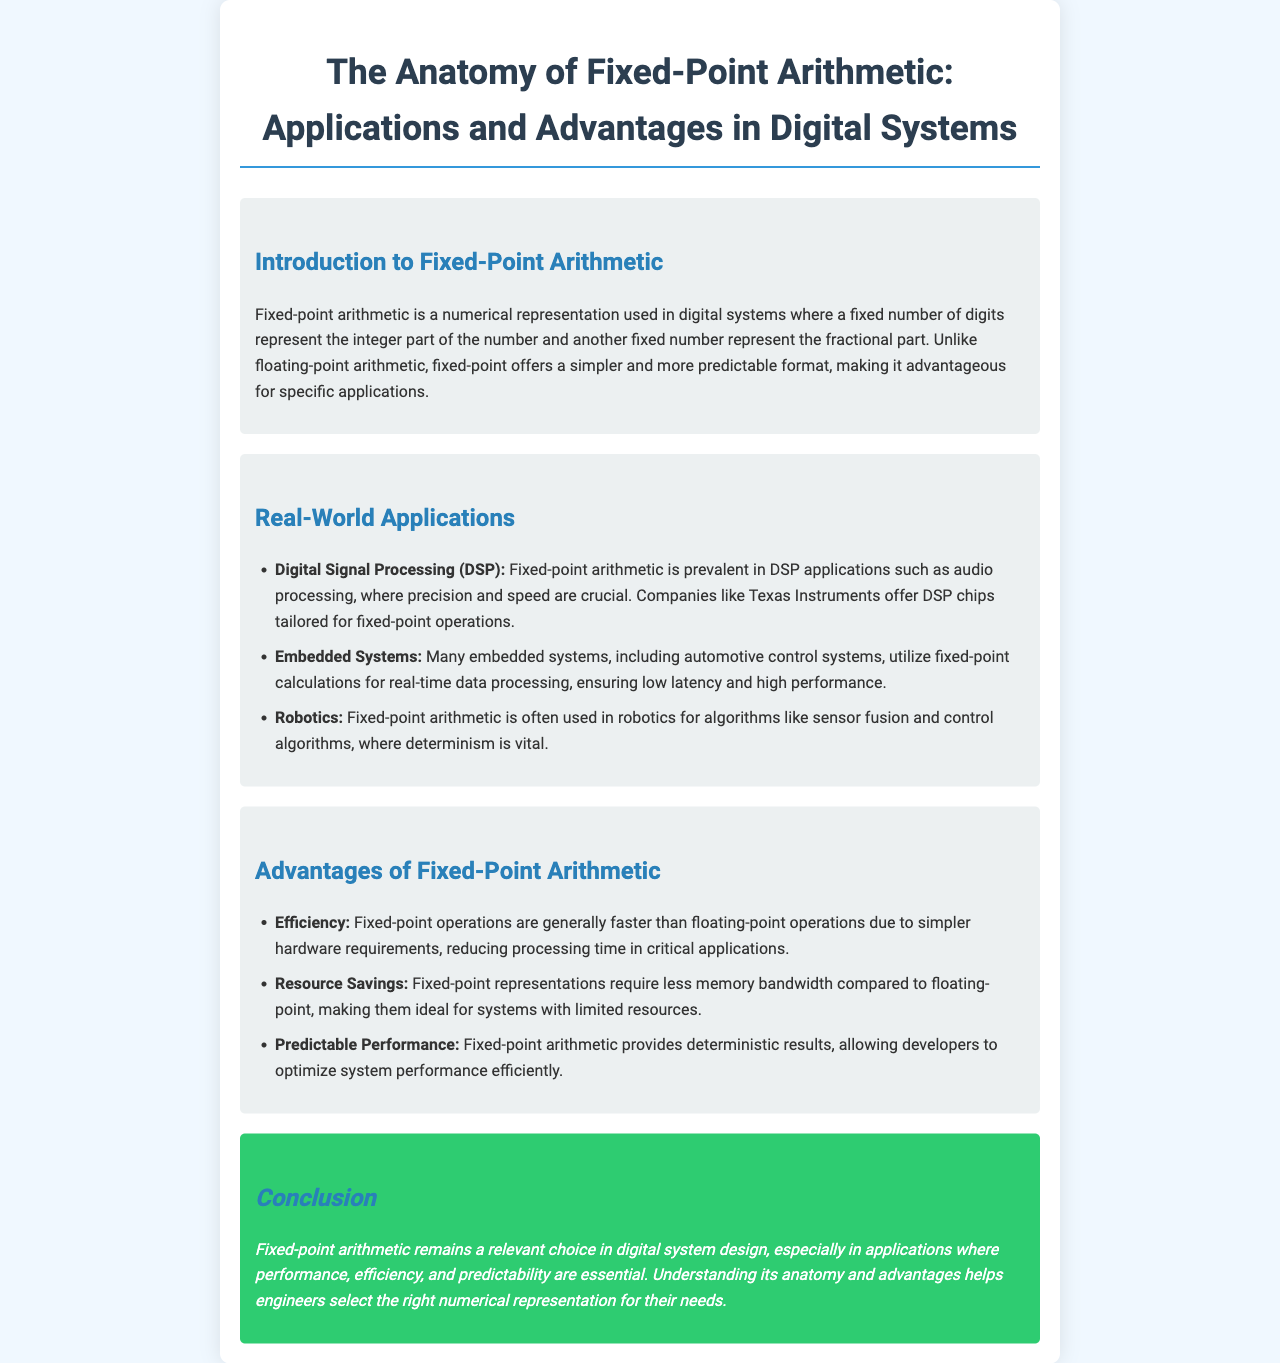What is the title of the document? The title is prominently displayed at the top of the document and summarizes its main focus on fixed-point arithmetic.
Answer: The Anatomy of Fixed-Point Arithmetic: Applications and Advantages in Digital Systems What is one application of fixed-point arithmetic mentioned in the document? The document lists various applications, which are explicitly detailed under the Real-World Applications section.
Answer: Digital Signal Processing (DSP) How does fixed-point arithmetic compare to floating-point in terms of simplicity? The document states that fixed-point arithmetic offers a simpler and more predictable format than floating-point arithmetic.
Answer: Simpler What is a key advantage of fixed-point arithmetic related to efficiency? The document highlights fast processing as a key advantage, specifically in the Advantages of Fixed-Point Arithmetic section.
Answer: Faster What type of systems utilize fixed-point arithmetic for real-time data processing? The Embedded Systems section details the use of fixed-point arithmetic in specific types of systems.
Answer: Automotive control systems Which company is mentioned as offering DSP chips for fixed-point operations? The document features a specific company that produces chips for these applications in the Real-World Applications section.
Answer: Texas Instruments What benefit does fixed-point arithmetic provide regarding performance predictability? The document elaborates on the deterministic results offered by fixed-point arithmetic in the Advantages section.
Answer: Deterministic results In which section is the conclusion found? The conclusion section wraps up the brochure and emphasizes the relevance of fixed-point arithmetic.
Answer: Conclusion What is the background color of the document? The document's style attributes specify the overall background color used for the body of the text.
Answer: Light blue 